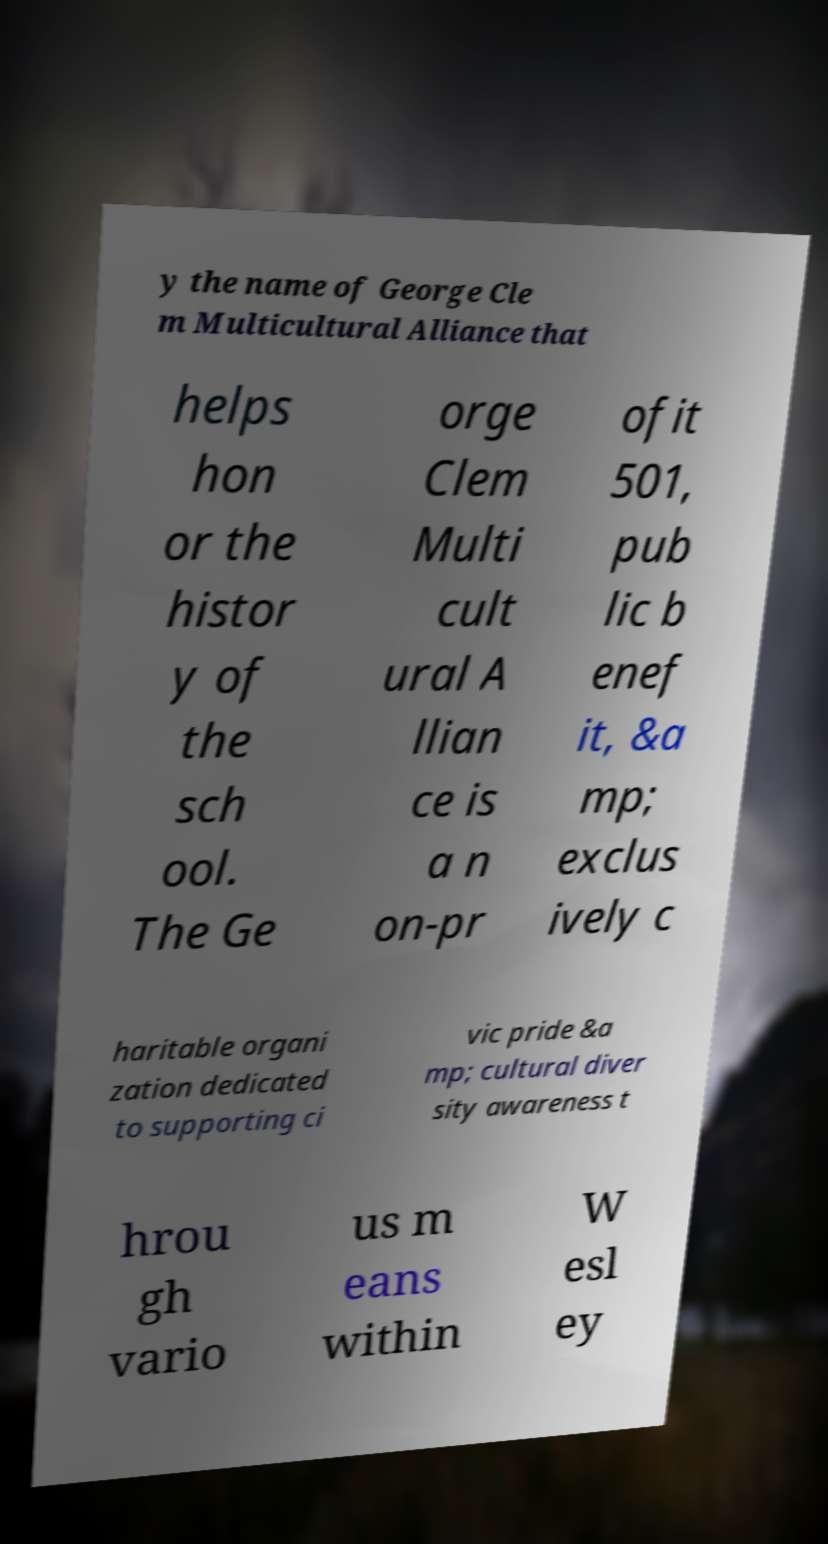There's text embedded in this image that I need extracted. Can you transcribe it verbatim? y the name of George Cle m Multicultural Alliance that helps hon or the histor y of the sch ool. The Ge orge Clem Multi cult ural A llian ce is a n on-pr ofit 501, pub lic b enef it, &a mp; exclus ively c haritable organi zation dedicated to supporting ci vic pride &a mp; cultural diver sity awareness t hrou gh vario us m eans within W esl ey 